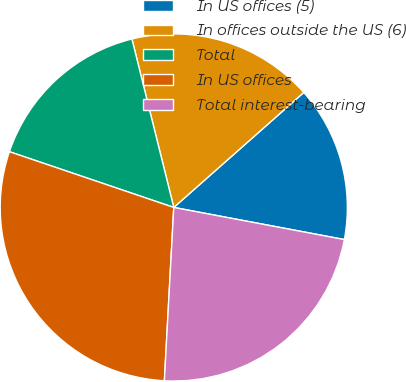Convert chart to OTSL. <chart><loc_0><loc_0><loc_500><loc_500><pie_chart><fcel>In US offices (5)<fcel>In offices outside the US (6)<fcel>Total<fcel>In US offices<fcel>Total interest-bearing<nl><fcel>14.49%<fcel>17.35%<fcel>15.92%<fcel>29.34%<fcel>22.9%<nl></chart> 